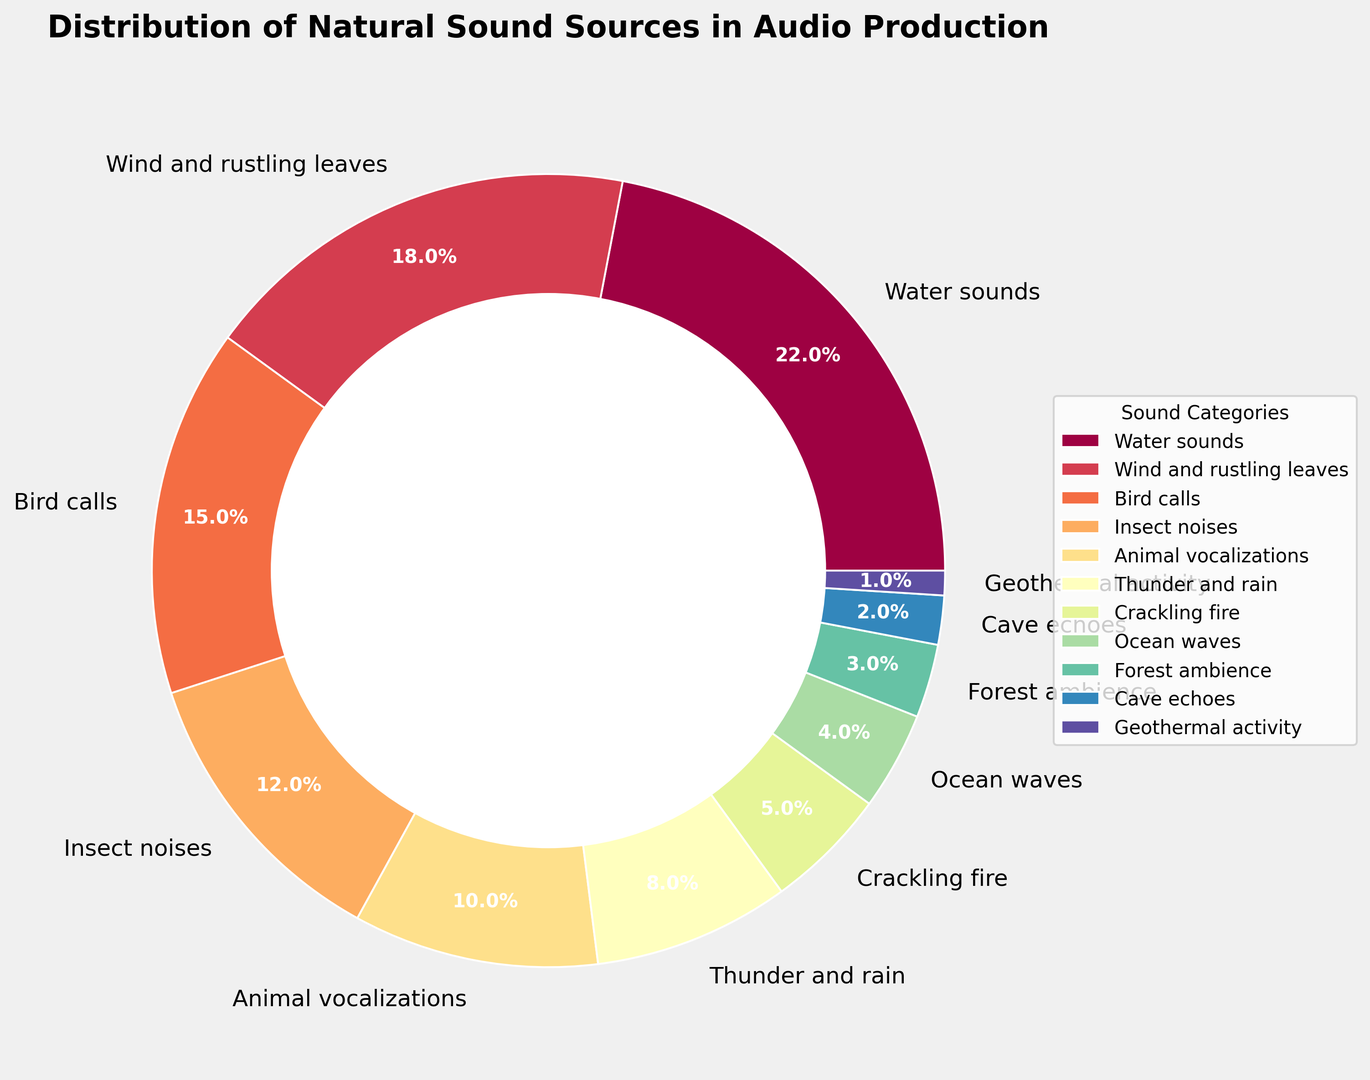What sound categories together make up exactly half of the pie chart? To find the categories that make up half of the pie chart, sum the percentages until you reach 50%. Water sounds (22%) + Wind and rustling leaves (18%) + Bird calls (15%) = 55%. Thus, the closest set without going over is Water sounds (22%) and Wind and rustling leaves (18%) + Bird calls (15%) = 55%
Answer: Water sounds, Wind and rustling leaves, Bird calls Which natural sound source occupies the smallest segment in the chart? Look for the category with the smallest percentage. The smallest percentage in the dataset is 1%.
Answer: Geothermal activity How do the combined percentages of Water sounds and Thunder and rain compare to Bird calls and Insect noises? The combined percentage for Water sounds and Thunder and rain is 22% + 8% = 30%. For Bird calls and Insect noises, it is 15% + 12% = 27%. Therefore 30% is greater than 27%.
Answer: 30% is greater than 27% Which categories have percentages less than 10%? Identify all categories with percentages less than 10%. These categories are Thunder and rain (8%), Crackling fire (5%), Ocean waves (4%), Forest ambience (3%), Cave echoes (2%), and Geothermal activity (1%).
Answer: Thunder and rain, Crackling fire, Ocean waves, Forest ambience, Cave echoes, Geothermal activity What is the difference in percentage between the largest and smallest segments? Identify the largest and smallest percentages in the chart, which are Water sounds (22%) and Geothermal activity (1%) respectively. Subtract the smallest percentage from the largest percentage: 22% - 1% = 21%.
Answer: 21% If you combine the percentages of Bird calls, Animal vocalizations, and Forest ambience, does their total percentage exceed that of Water sounds? The combined percentage of Bird calls (15%), Animal vocalizations (10%), and Forest ambience (3%) is 15% + 10% + 3% = 28%. Since Water sounds are 22%, 28% is indeed greater than 22%.
Answer: Yes Which source has the third largest segment in the pie chart? To find the third largest segment, list the categories with their percentages in descending order: Water sounds (22%), Wind and rustling leaves (18%), Bird calls (15%). The third largest is Bird calls.
Answer: Bird calls What is the total percentage for all the sound categories related to water (Water sounds, Thunder and rain, Ocean waves)? Sum the percentages of Water sounds (22%), Thunder and rain (8%), and Ocean waves (4%): 22% + 8% + 4% = 34%.
Answer: 34% Which category closely follows Wind and rustling leaves in terms of percentage share? Locate the percentage of Wind and rustling leaves (18%) and find the next close percentage. Bird calls at 15% is the closest.
Answer: Bird calls What percentage of the pie chart is occupied by animal-related sound categories (Bird calls, Insect noises, Animal vocalizations)? Sum the percentages of Bird calls (15%), Insect noises (12%), and Animal vocalizations (10%): 15% + 12% + 10% = 37%.
Answer: 37% 